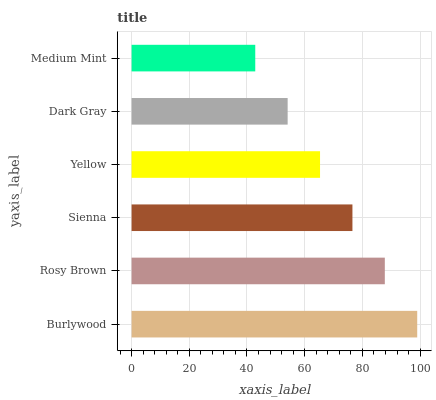Is Medium Mint the minimum?
Answer yes or no. Yes. Is Burlywood the maximum?
Answer yes or no. Yes. Is Rosy Brown the minimum?
Answer yes or no. No. Is Rosy Brown the maximum?
Answer yes or no. No. Is Burlywood greater than Rosy Brown?
Answer yes or no. Yes. Is Rosy Brown less than Burlywood?
Answer yes or no. Yes. Is Rosy Brown greater than Burlywood?
Answer yes or no. No. Is Burlywood less than Rosy Brown?
Answer yes or no. No. Is Sienna the high median?
Answer yes or no. Yes. Is Yellow the low median?
Answer yes or no. Yes. Is Burlywood the high median?
Answer yes or no. No. Is Sienna the low median?
Answer yes or no. No. 